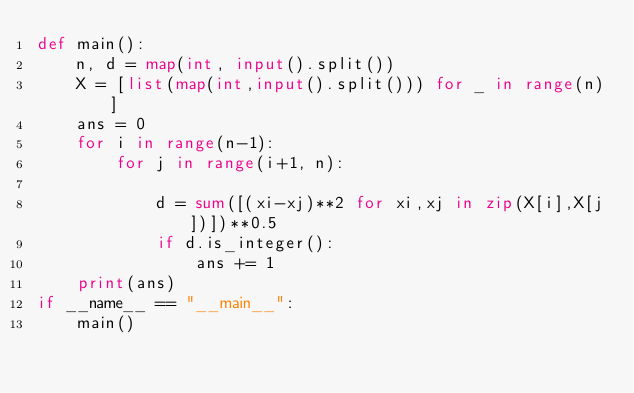Convert code to text. <code><loc_0><loc_0><loc_500><loc_500><_Python_>def main():
    n, d = map(int, input().split())
    X = [list(map(int,input().split())) for _ in range(n)]
    ans = 0
    for i in range(n-1):
        for j in range(i+1, n):

            d = sum([(xi-xj)**2 for xi,xj in zip(X[i],X[j])])**0.5
            if d.is_integer():
                ans += 1
    print(ans)
if __name__ == "__main__":
    main()</code> 